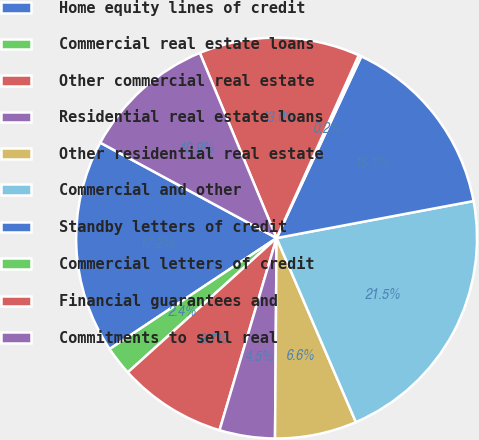<chart> <loc_0><loc_0><loc_500><loc_500><pie_chart><fcel>Home equity lines of credit<fcel>Commercial real estate loans<fcel>Other commercial real estate<fcel>Residential real estate loans<fcel>Other residential real estate<fcel>Commercial and other<fcel>Standby letters of credit<fcel>Commercial letters of credit<fcel>Financial guarantees and<fcel>Commitments to sell real<nl><fcel>17.23%<fcel>2.35%<fcel>8.72%<fcel>4.47%<fcel>6.6%<fcel>21.48%<fcel>15.1%<fcel>0.22%<fcel>12.98%<fcel>10.85%<nl></chart> 